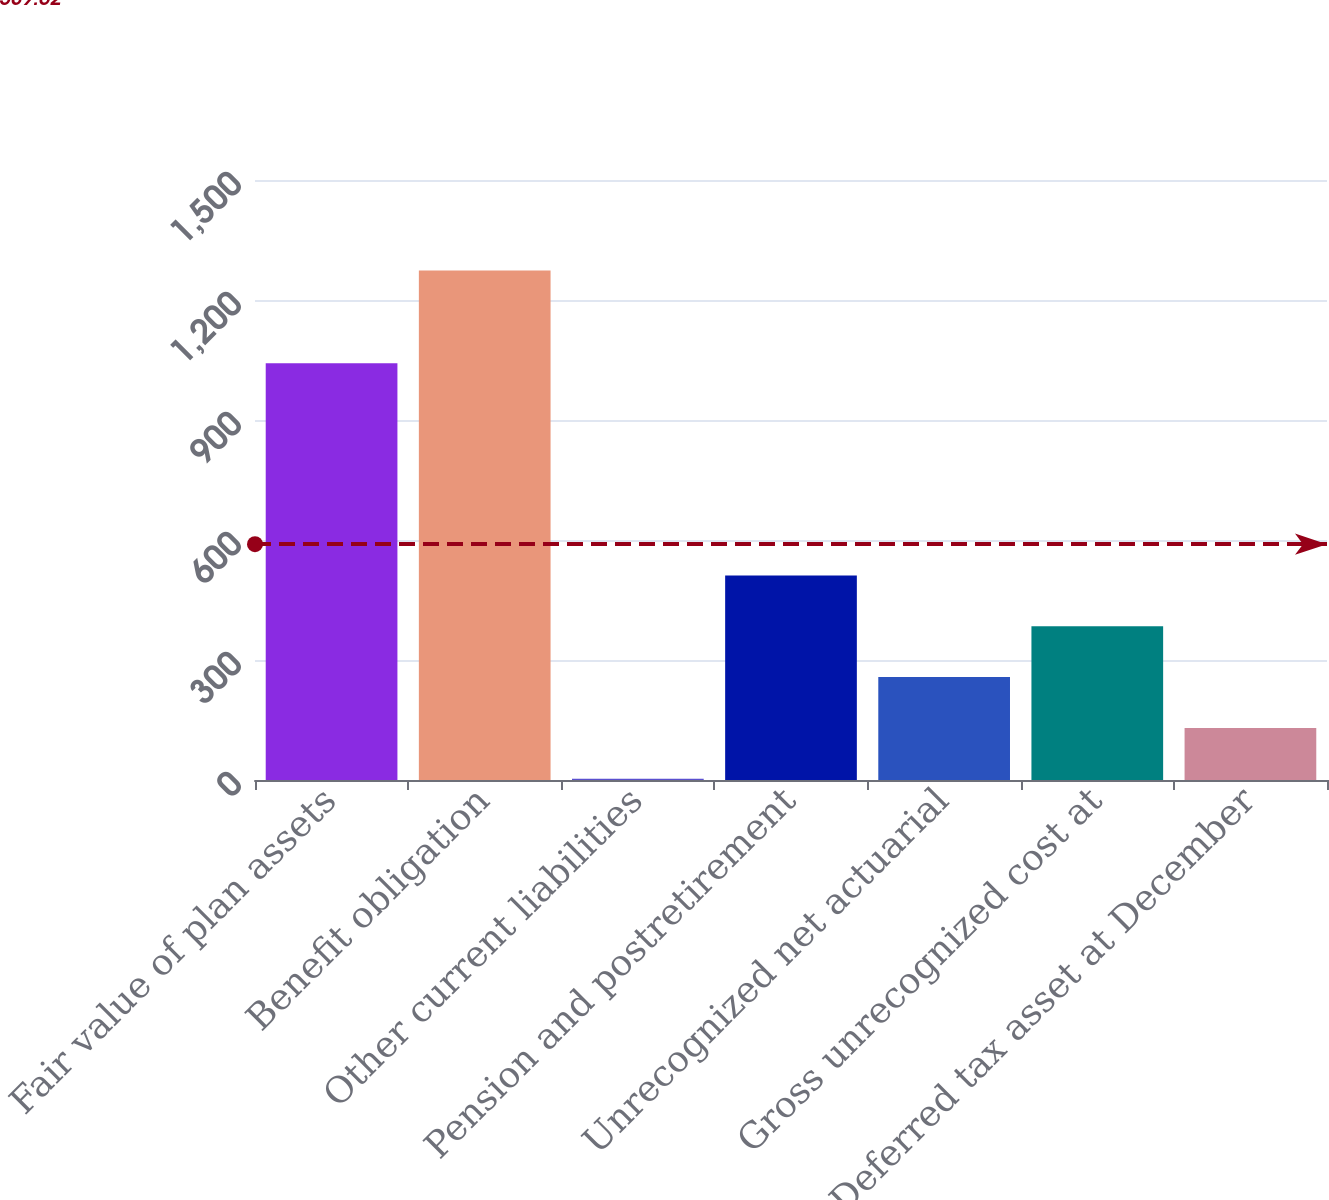<chart> <loc_0><loc_0><loc_500><loc_500><bar_chart><fcel>Fair value of plan assets<fcel>Benefit obligation<fcel>Other current liabilities<fcel>Pension and postretirement<fcel>Unrecognized net actuarial<fcel>Gross unrecognized cost at<fcel>Deferred tax asset at December<nl><fcel>1042<fcel>1274<fcel>3<fcel>511.4<fcel>257.2<fcel>384.3<fcel>130.1<nl></chart> 